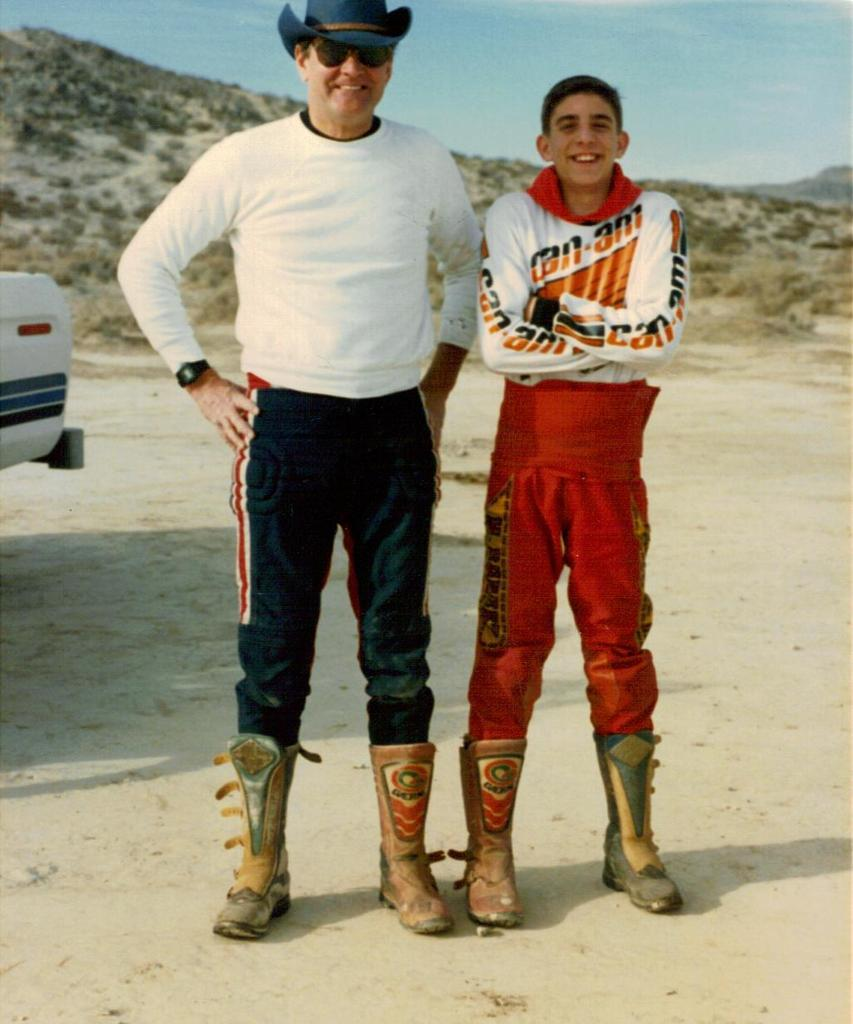Provide a one-sentence caption for the provided image. A young man wearing a Can Am racing outfit stands next to an older man. 